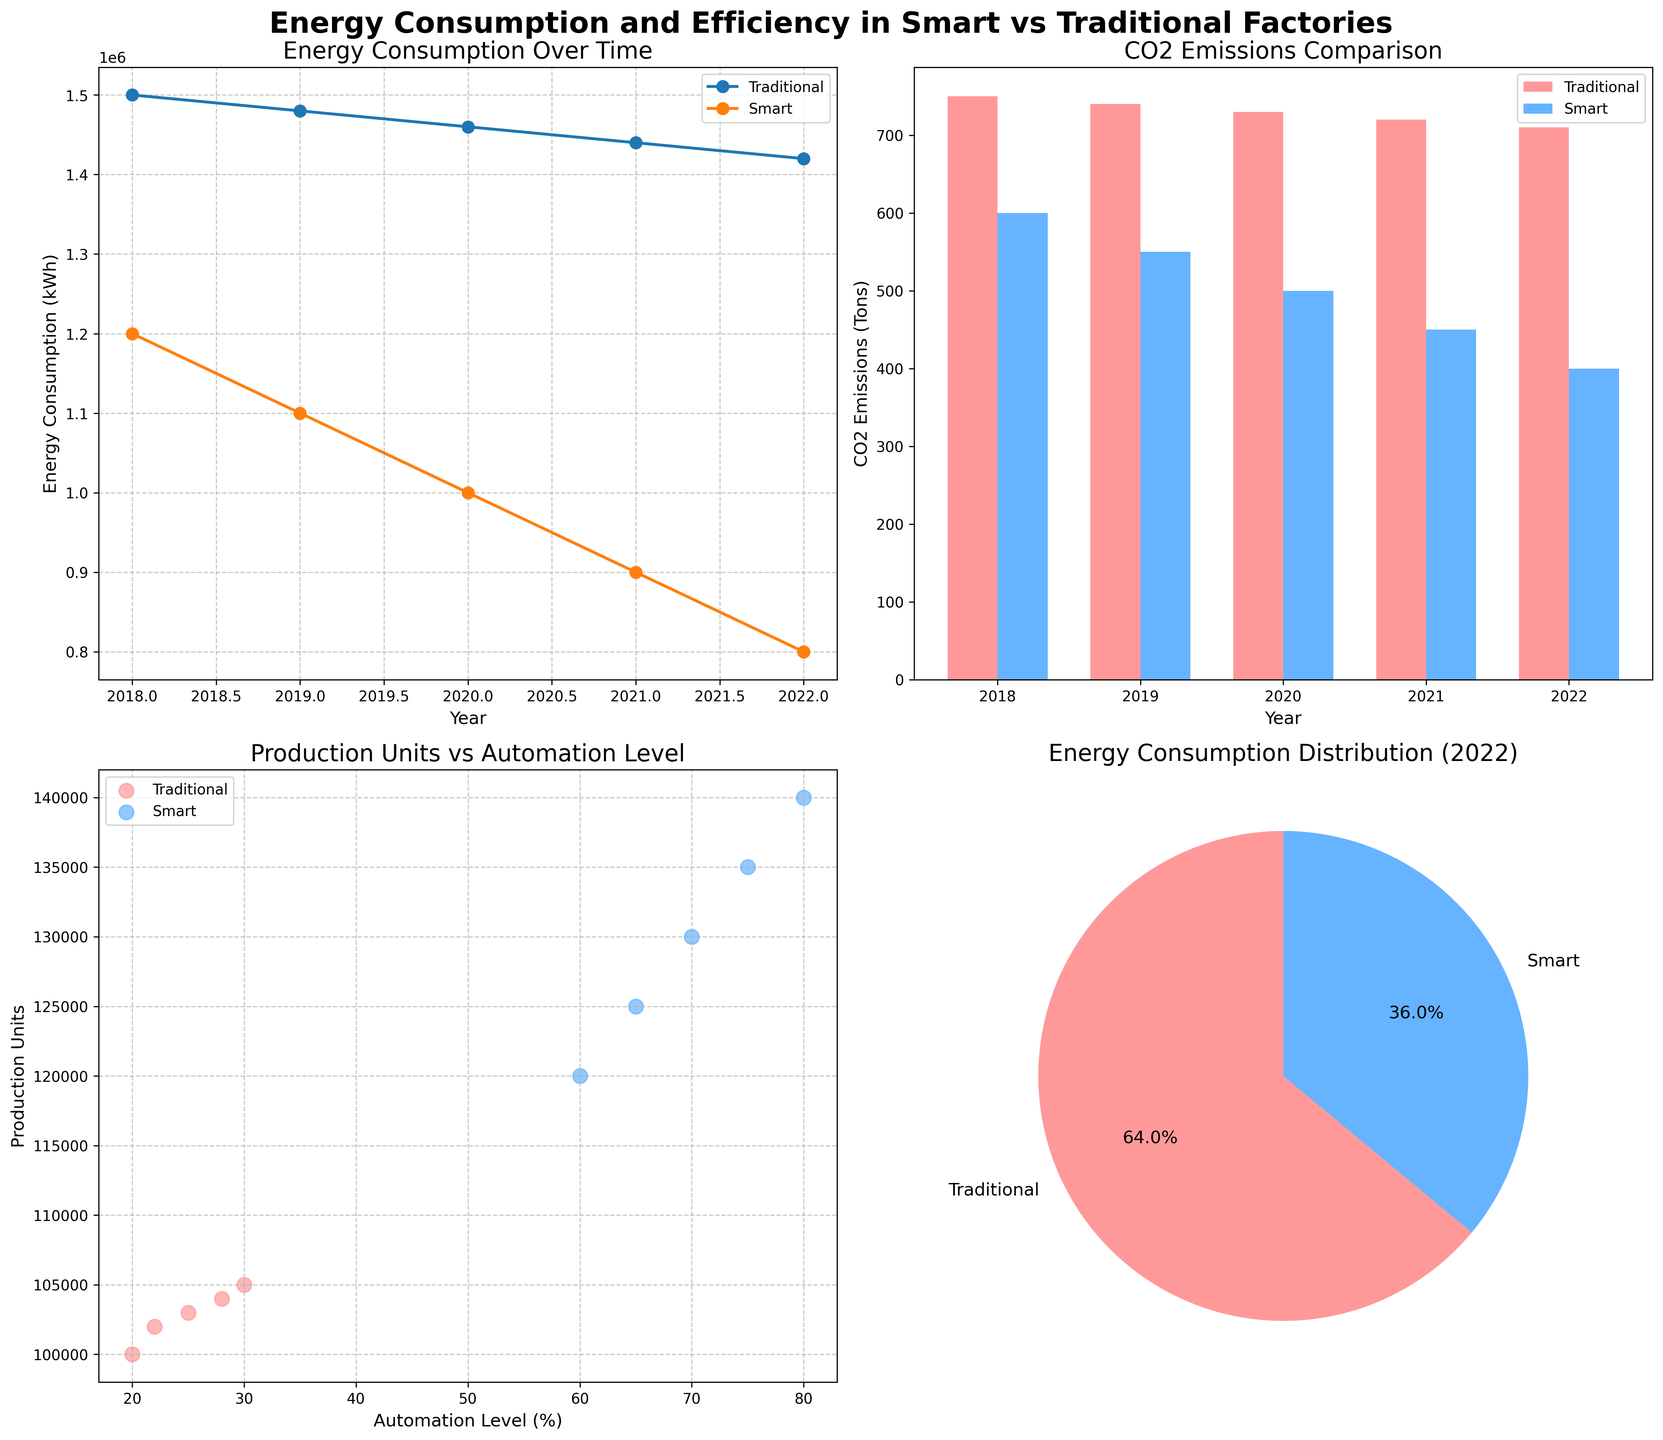What's the title of the figure? The title of the figure is clearly written at the top. Simply read the text.
Answer: Energy Consumption and Efficiency in Smart vs Traditional Factories What does the line plot in the top-left quadrant represent? The line plot in the top-left quadrant shows how energy consumption in both smart and traditional factories has changed over time. The axes indicate the focus on years (x-axis) and energy consumption in kWh (y-axis).
Answer: Energy Consumption Over Time Which factory type had higher CO2 emissions in 2020? By examining the bar plot in the top-right quadrant for the year 2020, we can see which bar is taller. The traditional factory has a higher bar, indicating more CO2 emissions.
Answer: Traditional In the scatter plot, what is the relationship between automation level and production units for smart factories? We can observe the scatter plot in the bottom-left quadrant to detect patterns. For smart factories represented by blue dots, as automation level increases, production units also increase.
Answer: Positive correlation Which year shows the lowest energy consumption for traditional factories? From the line plot in the top-left quadrant, look at the green line (traditional factories) and find the lowest point. The year corresponding to that point is the answer.
Answer: 2022 What percentage of the total energy consumption was used by smart factories in the latest year? The pie chart in the bottom-right quadrant shows the distribution of energy consumption in 2022. We can read the percentage directly from the chart.
Answer: 36.0% How did the CO2 emissions of smart factories change from 2018 to 2022? Observe the heights of the blue bars in the bar plot (top-right quadrant) for smart factories from 2018 to 2022. They show a decreasing trend.
Answer: Decreased The line plot shows data for how many years? The x-axis of the line plot in the top-left quadrant categorizes the years. Count the number of discrete points/years.
Answer: Five years Which factory type shows a more dramatic decrease in energy consumption from 2018 to 2022? Compare the slopes of the lines in the line plot (top-left quadrant). The blue line (smart factories) has a steeper slope indicating a more dramatic decrease.
Answer: Smart What is the automation level of traditional factories in 2021? Refer to the scatter plot in the bottom-left quadrant where the red points denote traditional factories. Locate the point for 2021 and read its automation level from the x-axis.
Answer: 28% 